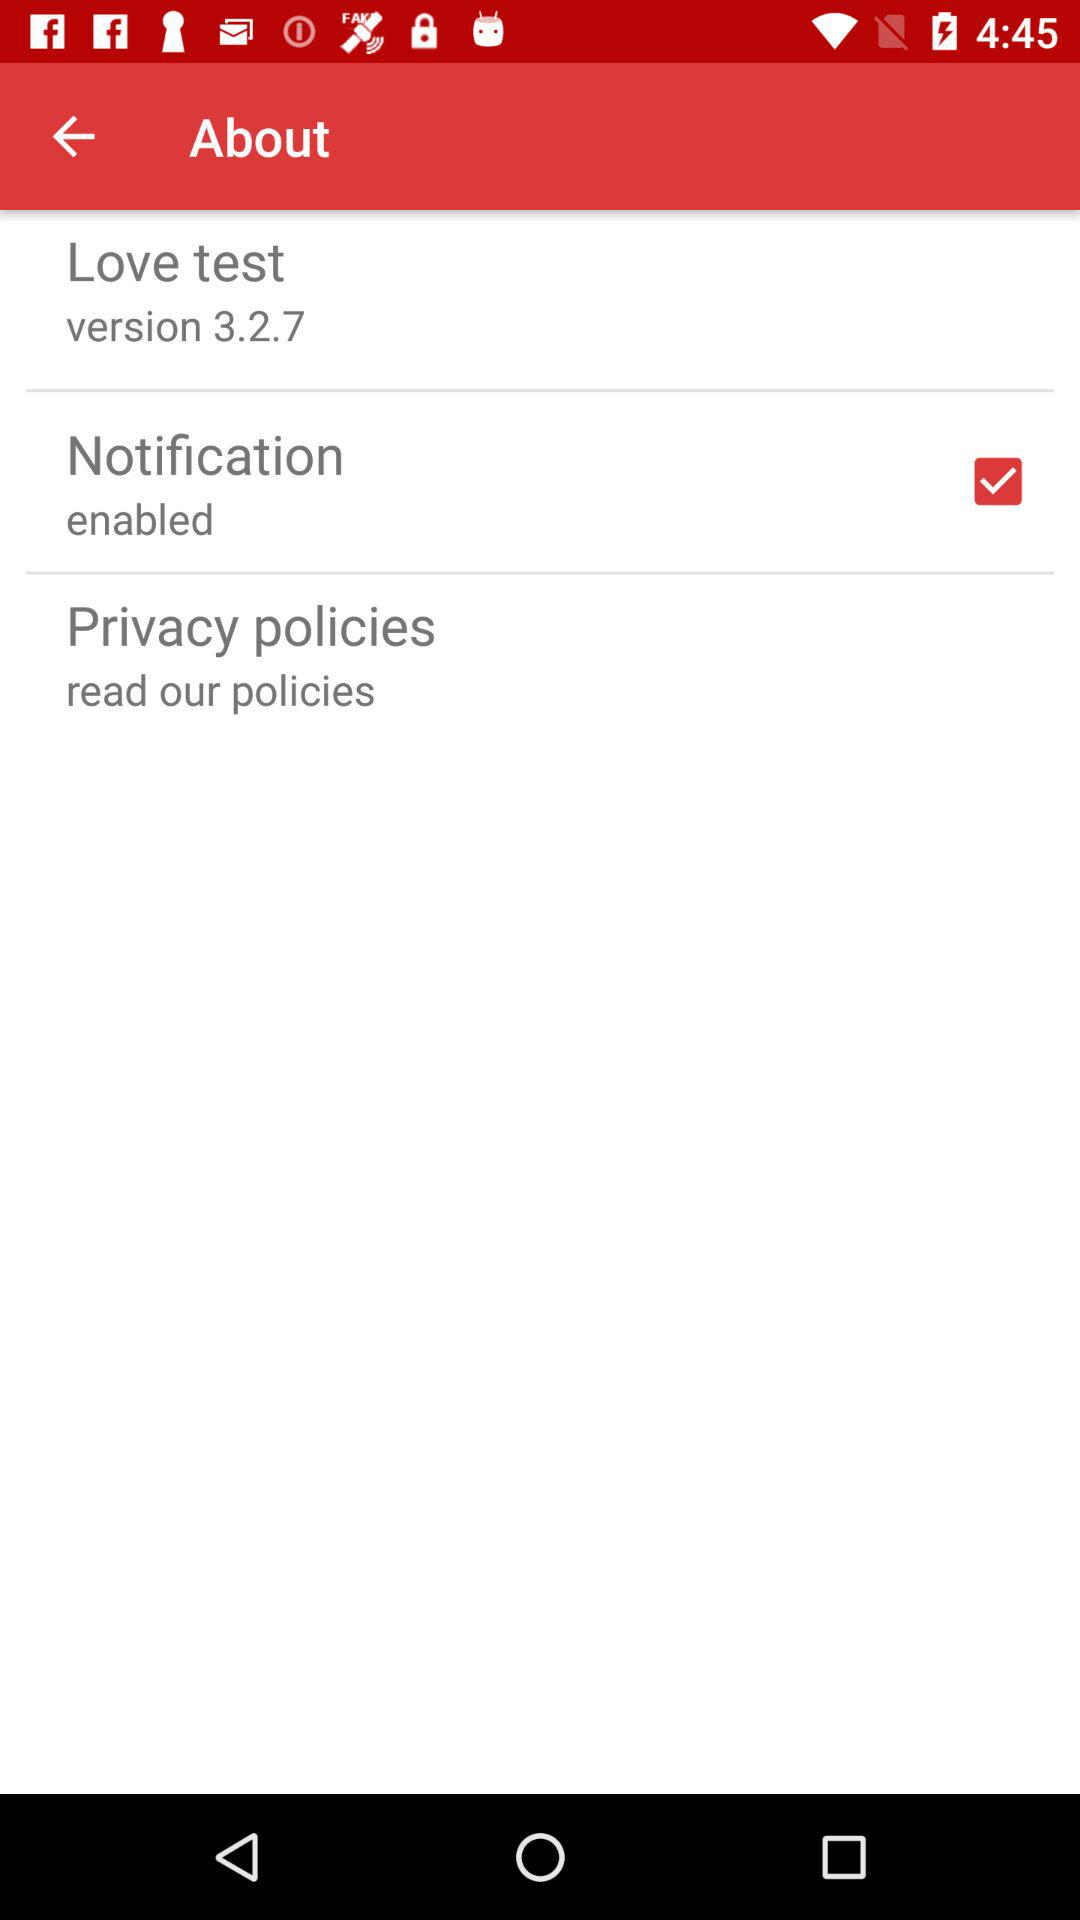What is the version of the "Love test"? The version is 3.2.7. 